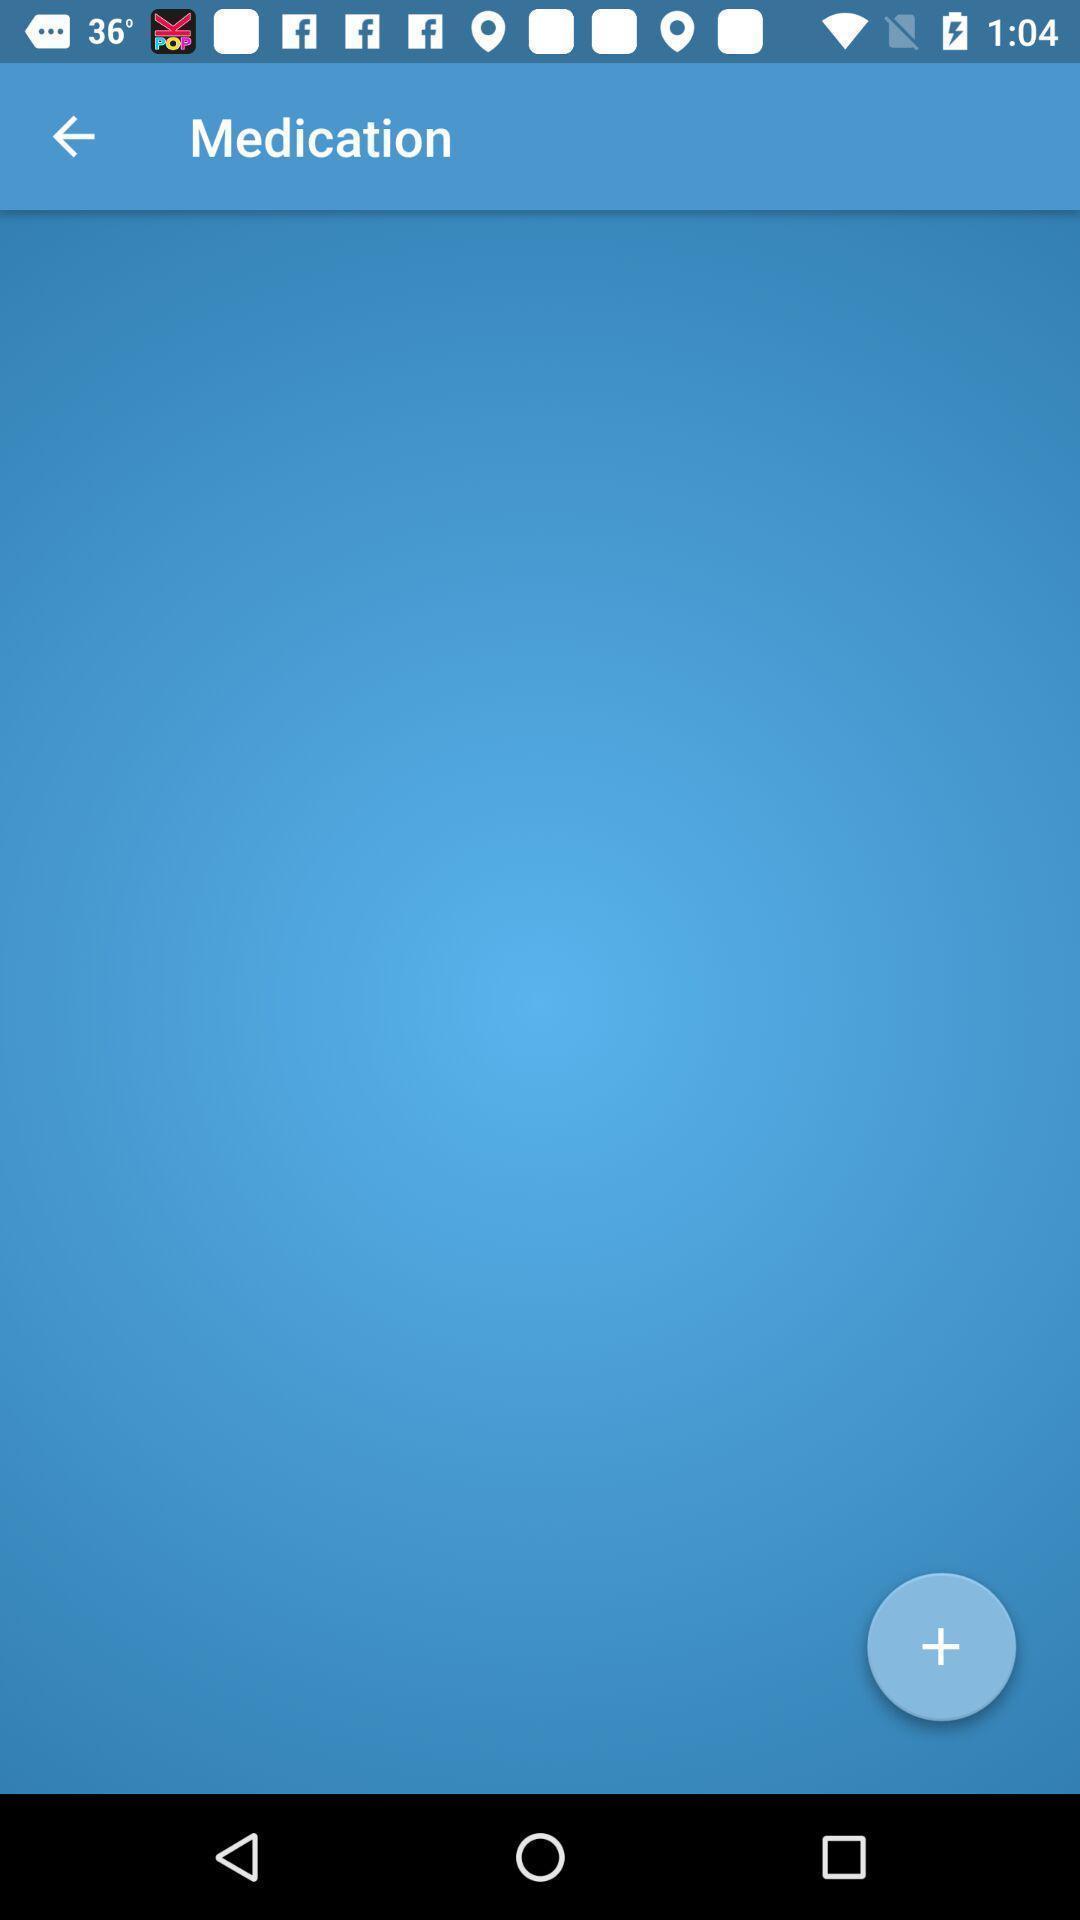Describe this image in words. Screen displaying medication page. 